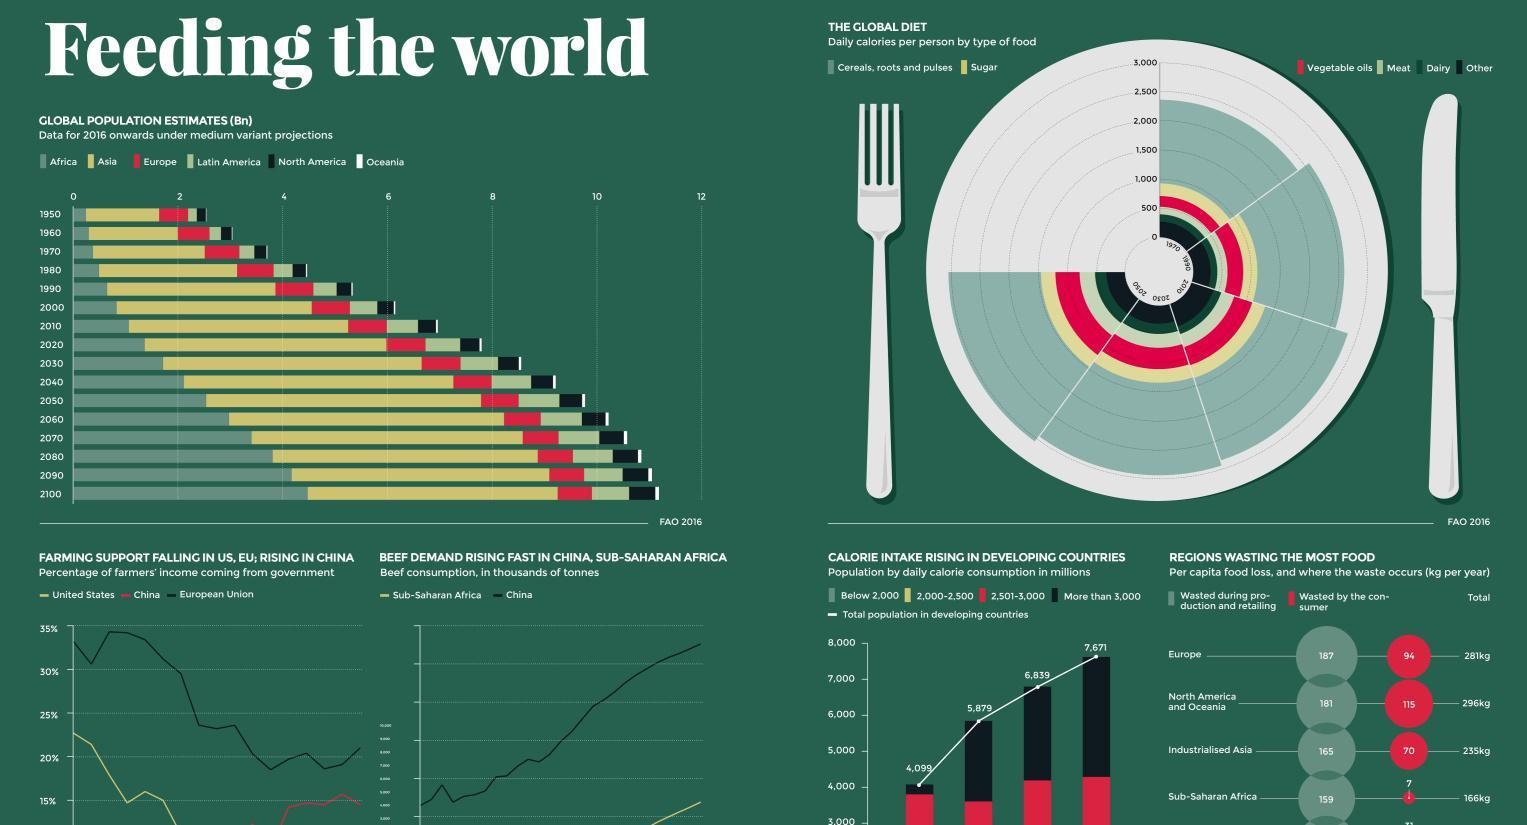By which year the daily calories per person will be more than 3000?
Answer the question with a short phrase. 2050 Around which year was the daily calories per person lower than 2500? 1970 By which year is the total global population estimated to cross 10 billion? 2060 